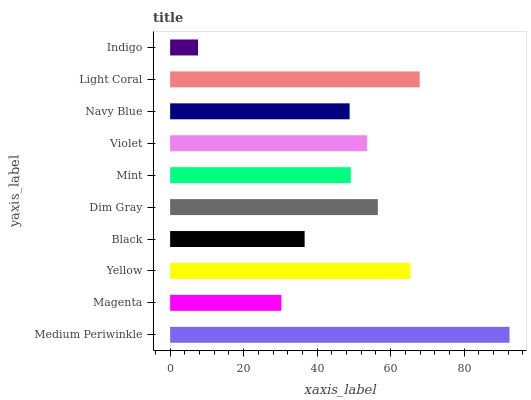Is Indigo the minimum?
Answer yes or no. Yes. Is Medium Periwinkle the maximum?
Answer yes or no. Yes. Is Magenta the minimum?
Answer yes or no. No. Is Magenta the maximum?
Answer yes or no. No. Is Medium Periwinkle greater than Magenta?
Answer yes or no. Yes. Is Magenta less than Medium Periwinkle?
Answer yes or no. Yes. Is Magenta greater than Medium Periwinkle?
Answer yes or no. No. Is Medium Periwinkle less than Magenta?
Answer yes or no. No. Is Violet the high median?
Answer yes or no. Yes. Is Mint the low median?
Answer yes or no. Yes. Is Yellow the high median?
Answer yes or no. No. Is Violet the low median?
Answer yes or no. No. 